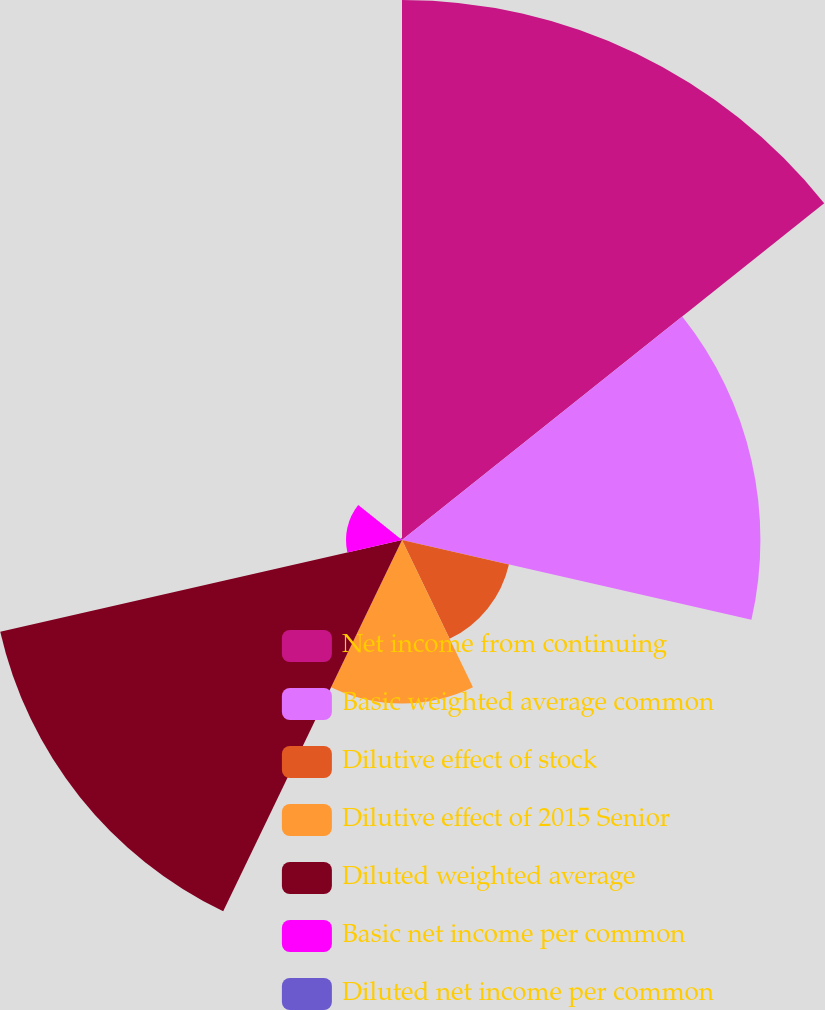Convert chart to OTSL. <chart><loc_0><loc_0><loc_500><loc_500><pie_chart><fcel>Net income from continuing<fcel>Basic weighted average common<fcel>Dilutive effect of stock<fcel>Dilutive effect of 2015 Senior<fcel>Diluted weighted average<fcel>Basic net income per common<fcel>Diluted net income per common<nl><fcel>32.89%<fcel>21.83%<fcel>6.68%<fcel>9.96%<fcel>25.1%<fcel>3.41%<fcel>0.13%<nl></chart> 